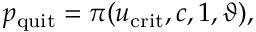Convert formula to latex. <formula><loc_0><loc_0><loc_500><loc_500>p _ { q u i t } = \pi ( u _ { c r i t } , c , 1 , \vartheta ) ,</formula> 